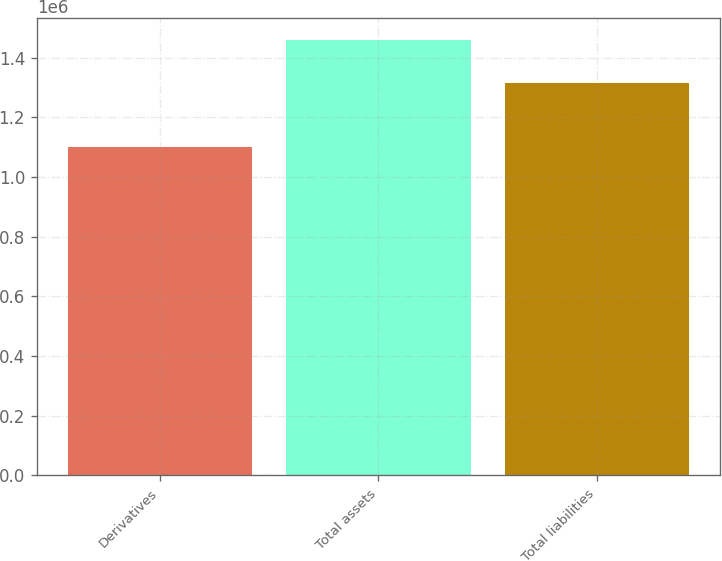Convert chart. <chart><loc_0><loc_0><loc_500><loc_500><bar_chart><fcel>Derivatives<fcel>Total assets<fcel>Total liabilities<nl><fcel>1.10225e+06<fcel>1.45977e+06<fcel>1.31453e+06<nl></chart> 